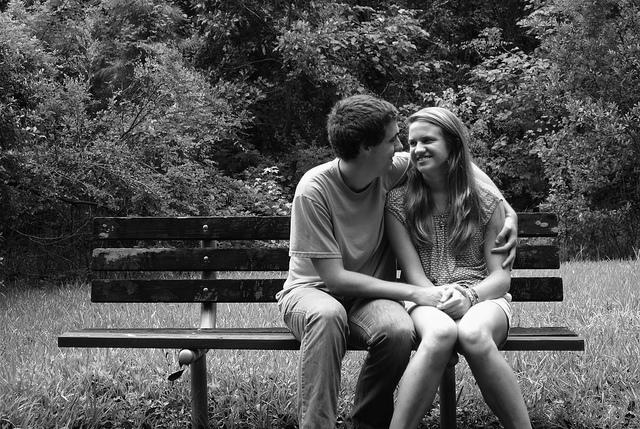Does the man look sad?
Short answer required. No. Do these two know each other?
Answer briefly. Yes. Are these children related?
Short answer required. No. Is this couple having an argument?
Keep it brief. No. Does this picture look old?
Be succinct. No. 